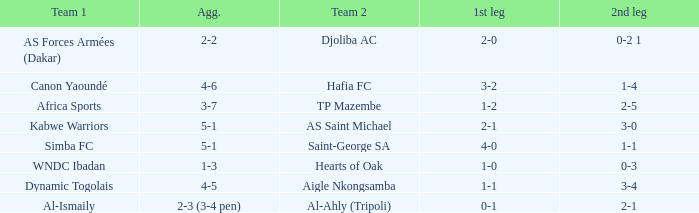Would you mind parsing the complete table? {'header': ['Team 1', 'Agg.', 'Team 2', '1st leg', '2nd leg'], 'rows': [['AS Forces Armées (Dakar)', '2-2', 'Djoliba AC', '2-0', '0-2 1'], ['Canon Yaoundé', '4-6', 'Hafia FC', '3-2', '1-4'], ['Africa Sports', '3-7', 'TP Mazembe', '1-2', '2-5'], ['Kabwe Warriors', '5-1', 'AS Saint Michael', '2-1', '3-0'], ['Simba FC', '5-1', 'Saint-George SA', '4-0', '1-1'], ['WNDC Ibadan', '1-3', 'Hearts of Oak', '1-0', '0-3'], ['Dynamic Togolais', '4-5', 'Aigle Nkongsamba', '1-1', '3-4'], ['Al-Ismaily', '2-3 (3-4 pen)', 'Al-Ahly (Tripoli)', '0-1', '2-1']]} What team played against Al-Ismaily (team 1)? Al-Ahly (Tripoli). 